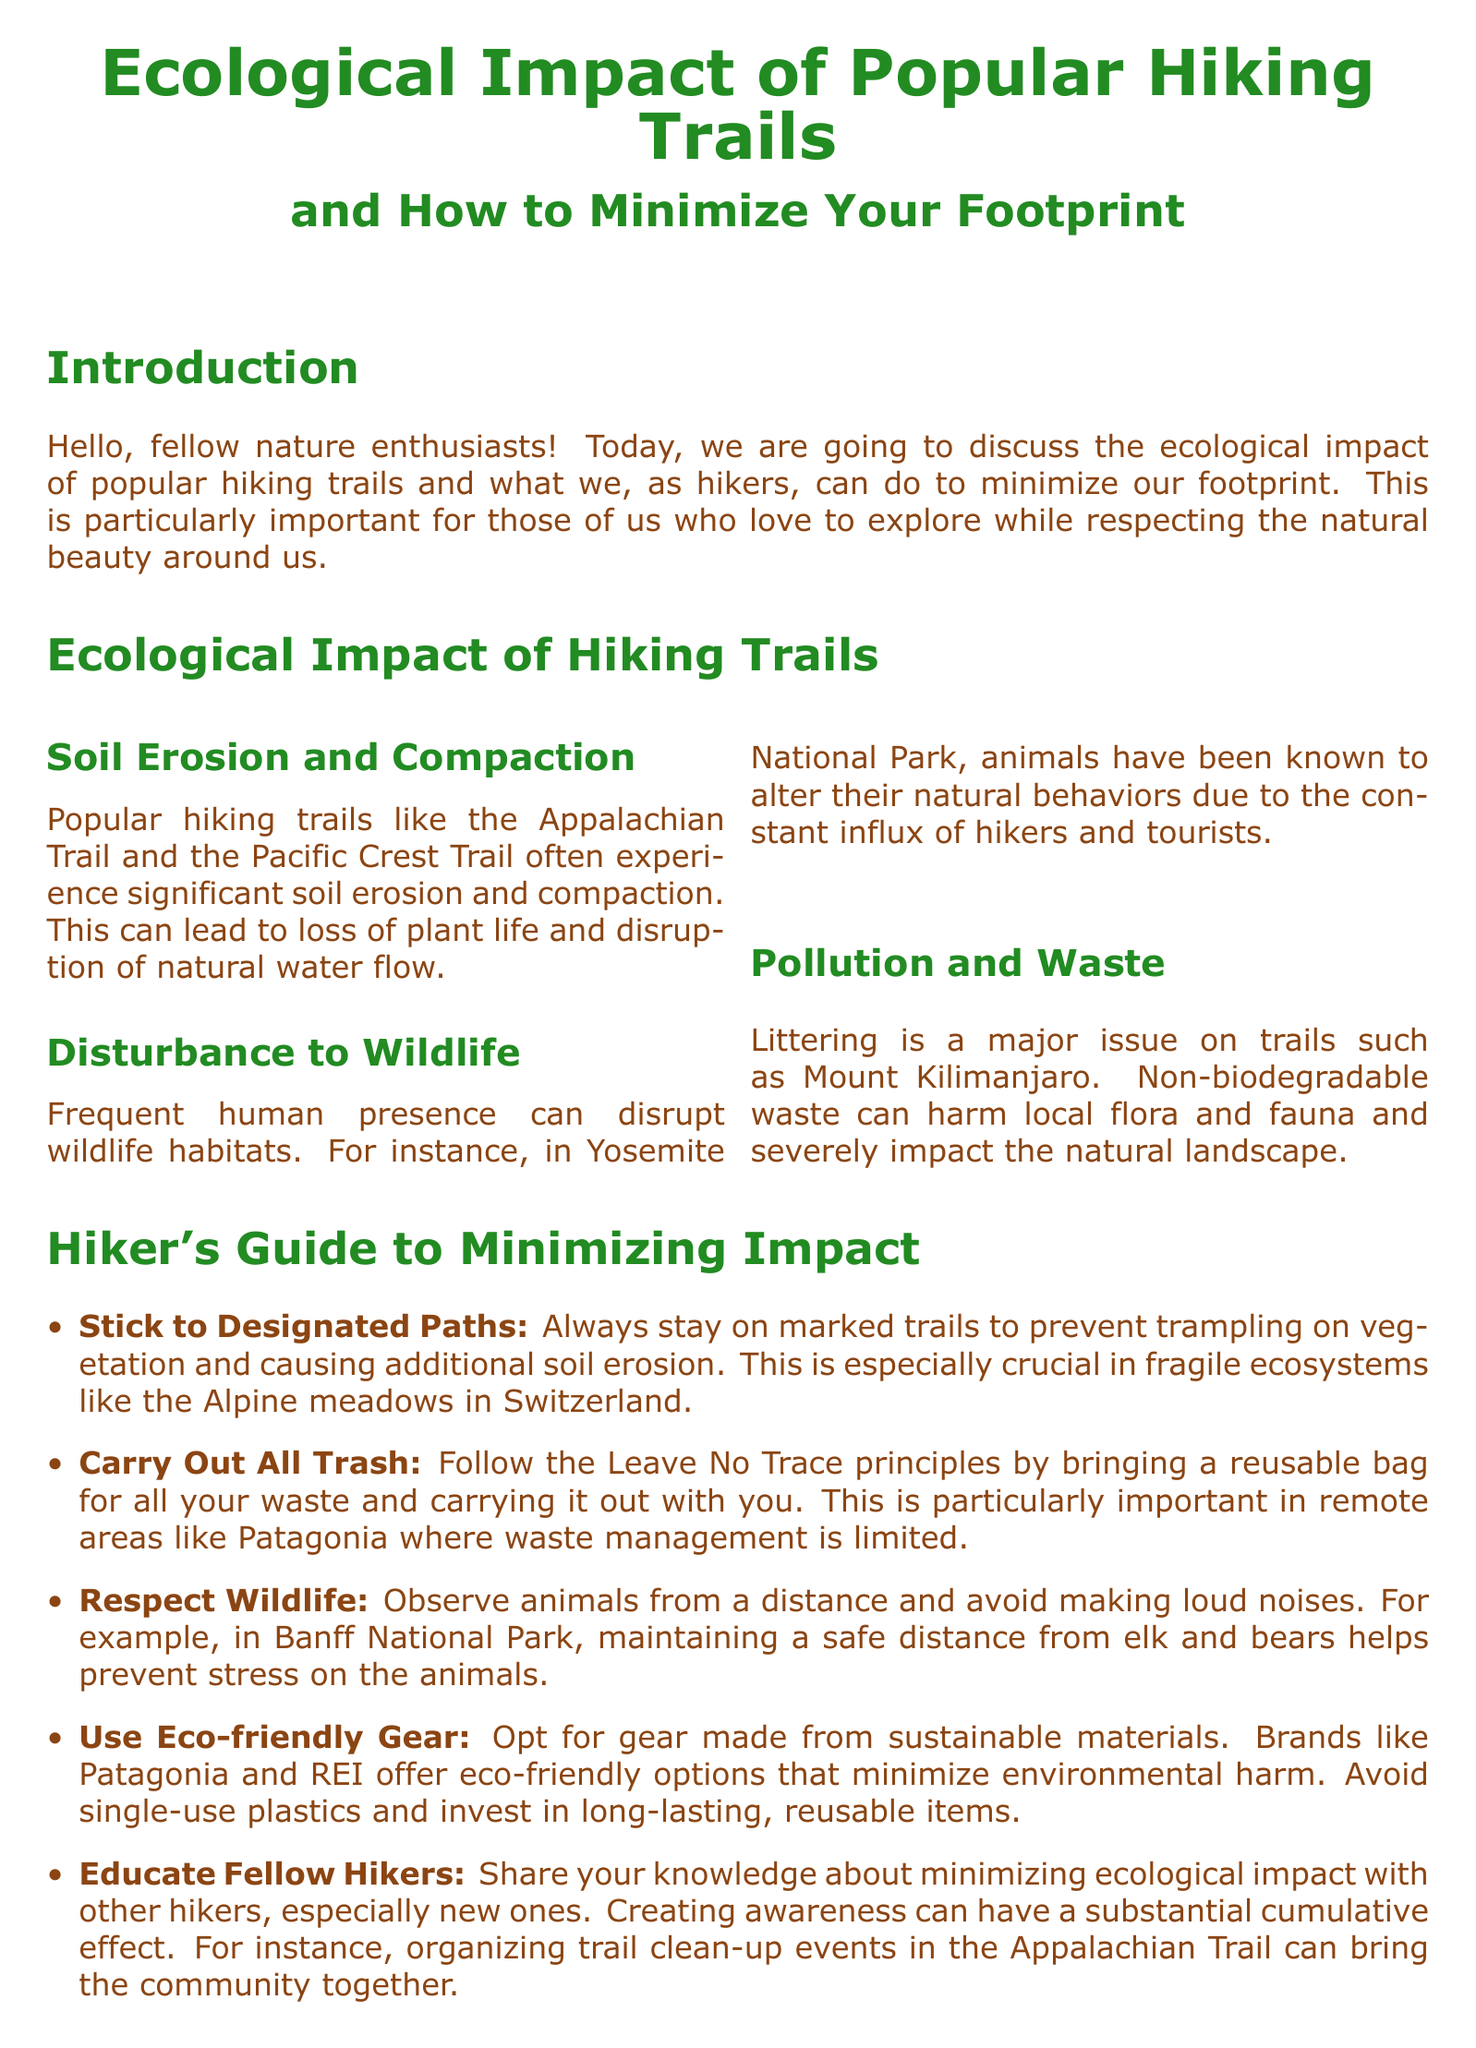What is the main topic discussed in the document? The document discusses the ecological impact of popular hiking trails and ways to minimize hikers' footprints.
Answer: Ecological impact of popular hiking trails What are the two popular hiking trails mentioned? The document lists the Appalachian Trail and the Pacific Crest Trail as examples of popular hiking trails.
Answer: Appalachian Trail, Pacific Crest Trail What is one of the major issues faced by popular hiking trails? The document states that littering is a major issue on trails like Mount Kilimanjaro.
Answer: Littering What principle should hikers follow regarding trash? The document suggests following the Leave No Trace principles, which encourages carrying out trash.
Answer: Carry out all trash Which national park is mentioned in relation to wildlife disturbance? The document references Yosemite National Park as an area where human presence disrupts wildlife.
Answer: Yosemite National Park What should hikers do to respect wildlife? The document advises hikers to observe animals from a distance to prevent stress on them.
Answer: Observe from a distance Which brand is recommended for eco-friendly gear? Patagonia and REI are suggested as brands that offer eco-friendly options.
Answer: Patagonia, REI How can hikers help educate others? The document mentions that sharing knowledge about minimizing ecological impact can help educate fellow hikers.
Answer: Share knowledge What is the overall goal of the document? The main goal is to ensure hiking trails remain pristine for future generations.
Answer: Pristine trails for future generations 